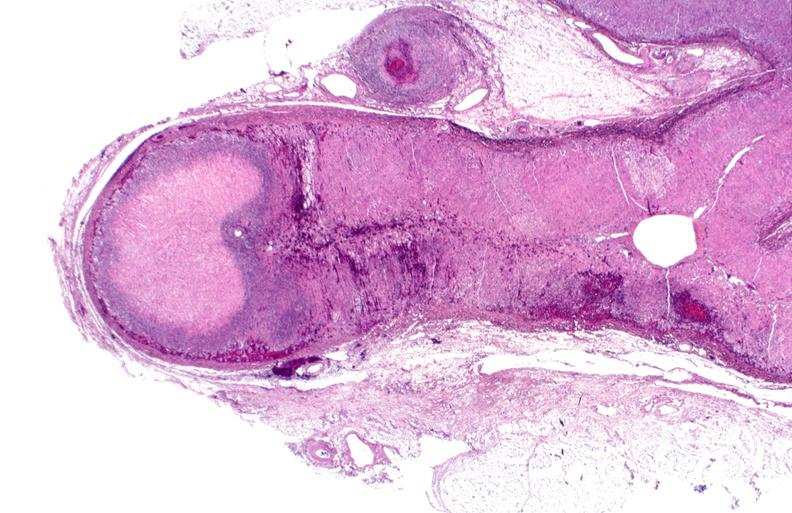what is present?
Answer the question using a single word or phrase. Endocrine 